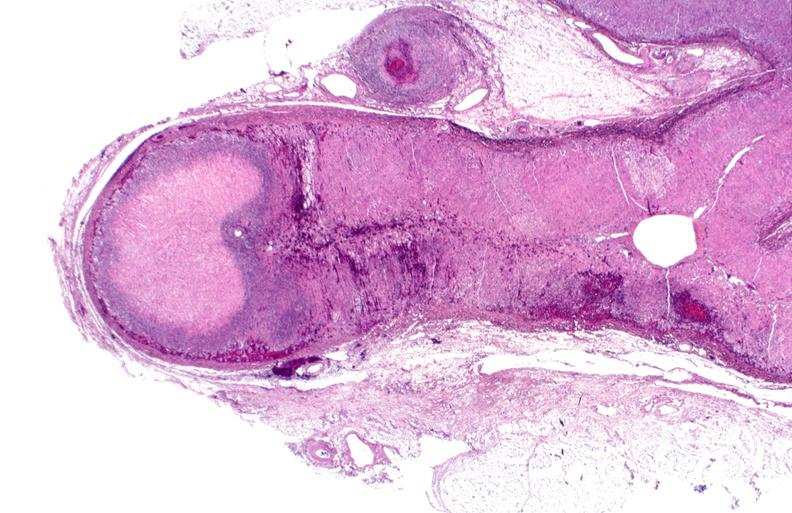what is present?
Answer the question using a single word or phrase. Endocrine 